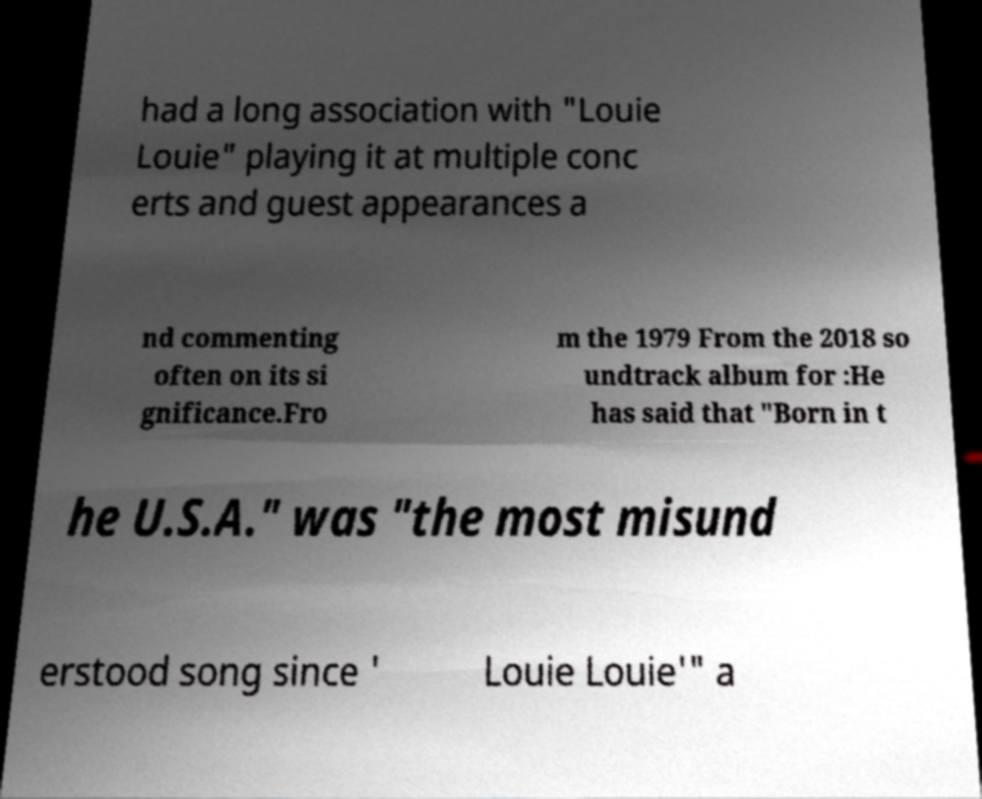Can you read and provide the text displayed in the image?This photo seems to have some interesting text. Can you extract and type it out for me? had a long association with "Louie Louie" playing it at multiple conc erts and guest appearances a nd commenting often on its si gnificance.Fro m the 1979 From the 2018 so undtrack album for :He has said that "Born in t he U.S.A." was "the most misund erstood song since ' Louie Louie'" a 